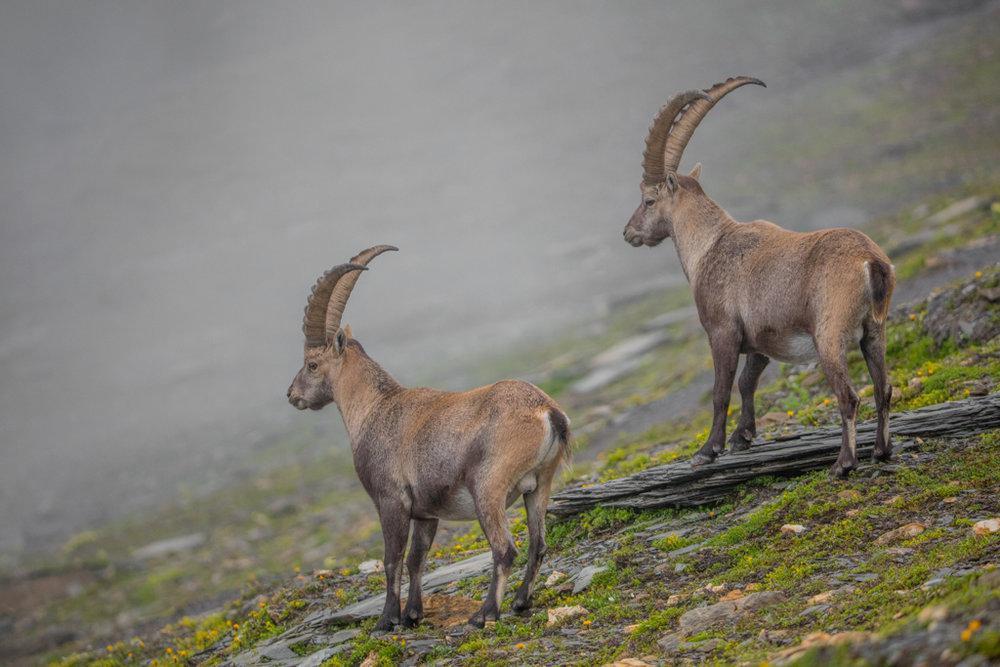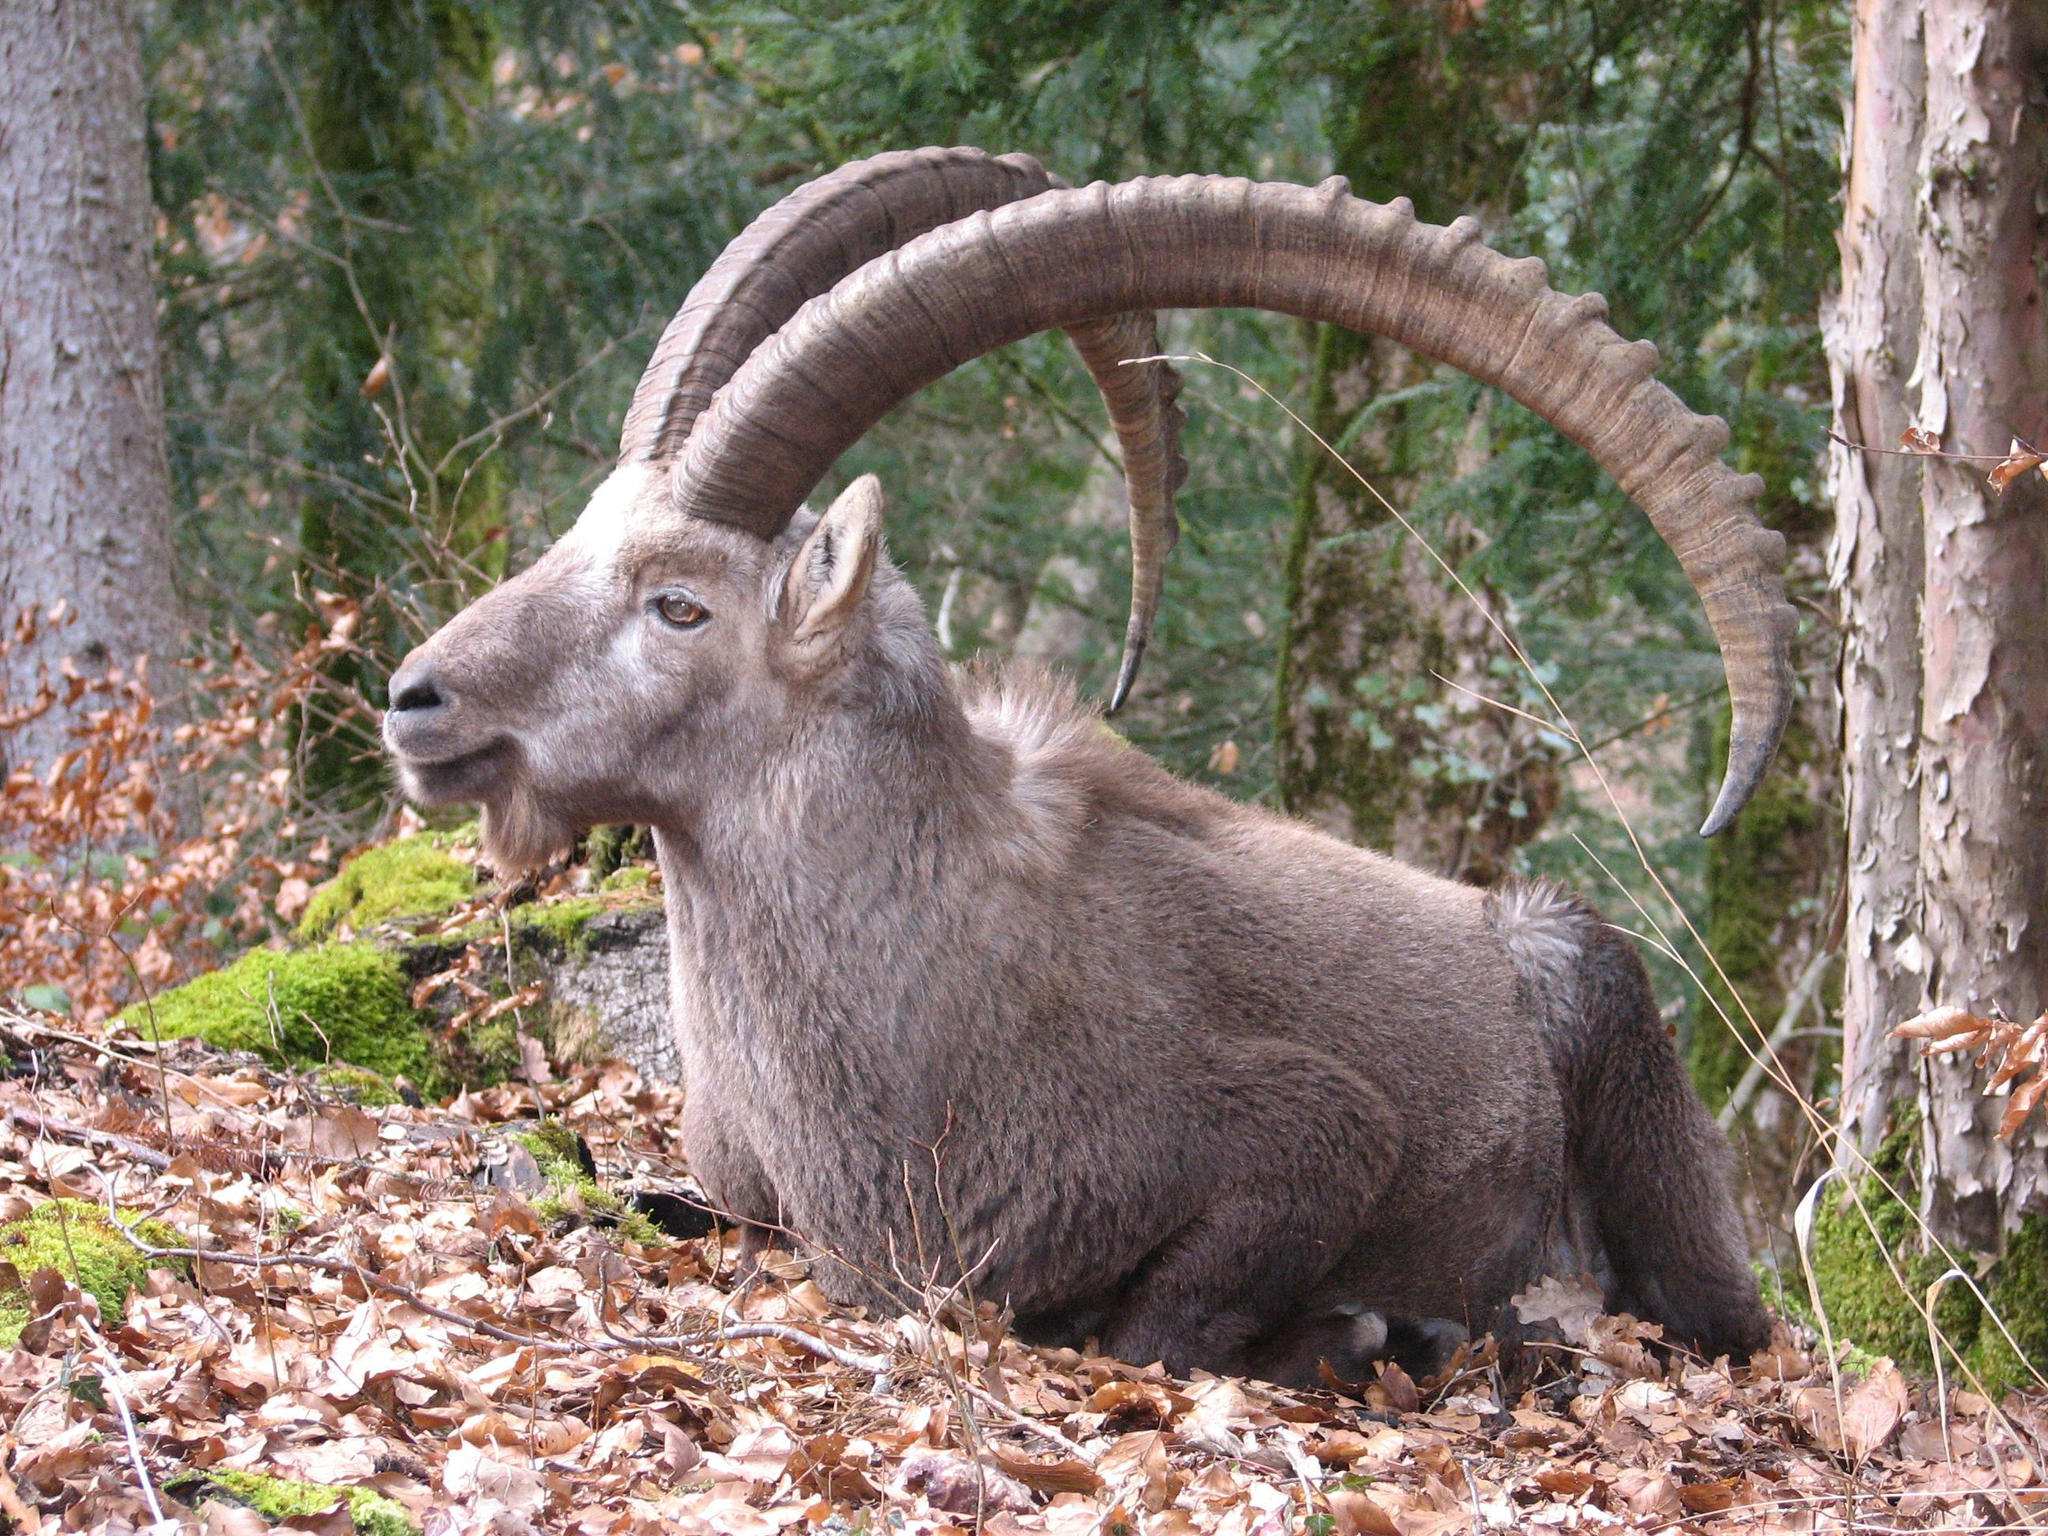The first image is the image on the left, the second image is the image on the right. For the images displayed, is the sentence "At least one man is posed behind a downed long-horned animal in one image." factually correct? Answer yes or no. No. The first image is the image on the left, the second image is the image on the right. Analyze the images presented: Is the assertion "At least one person is posing with a horned animal in one of the pictures." valid? Answer yes or no. No. 